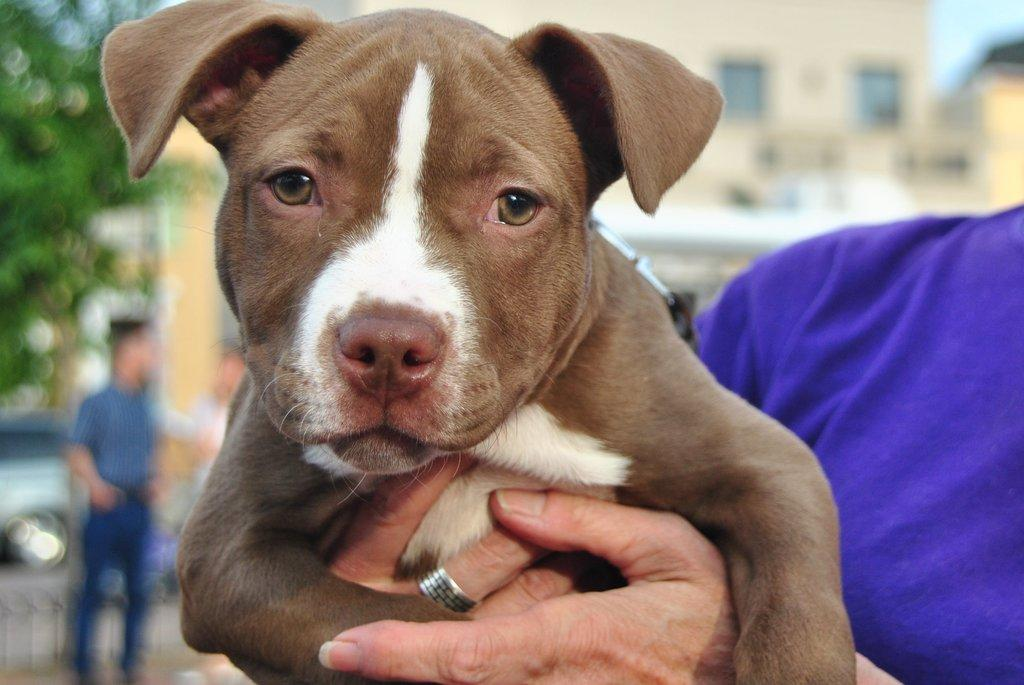What is the person in the image holding? The person is holding a dog in the image. Can you describe the scene in the background? In the background of the image, there are people, vehicles, trees, and buildings. How many people are visible in the image? There is one person holding a dog, and there are people in the background, but the exact number is not specified. What type of environment is depicted in the image? The image shows an urban environment with buildings and vehicles. What type of haircut does the dog have in the image? The image does not provide information about the dog's haircut. What month is it in the image? The image does not provide information about the month or time of year. 